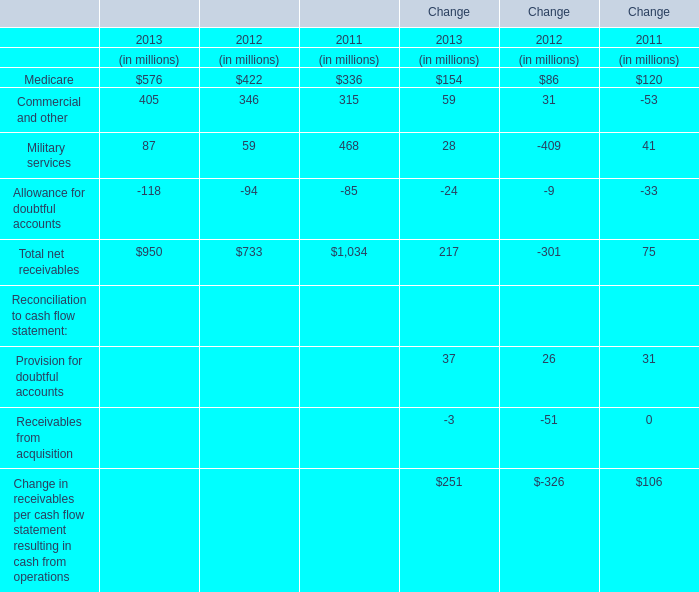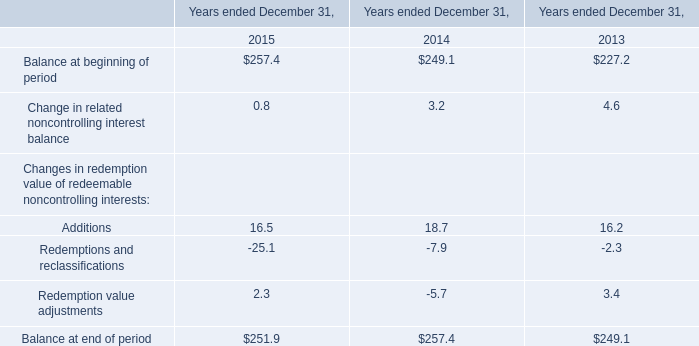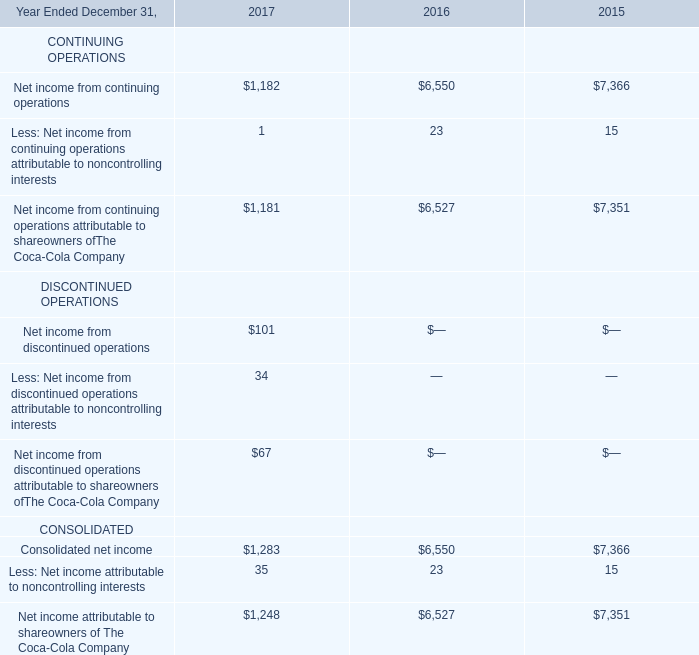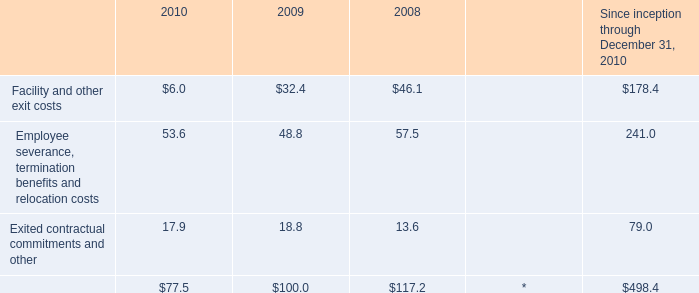What is the sum of Balance at beginning of period in 2015 and Net income from continuing operations in 2017? 
Computations: (257.4 + 1182)
Answer: 1439.4. 